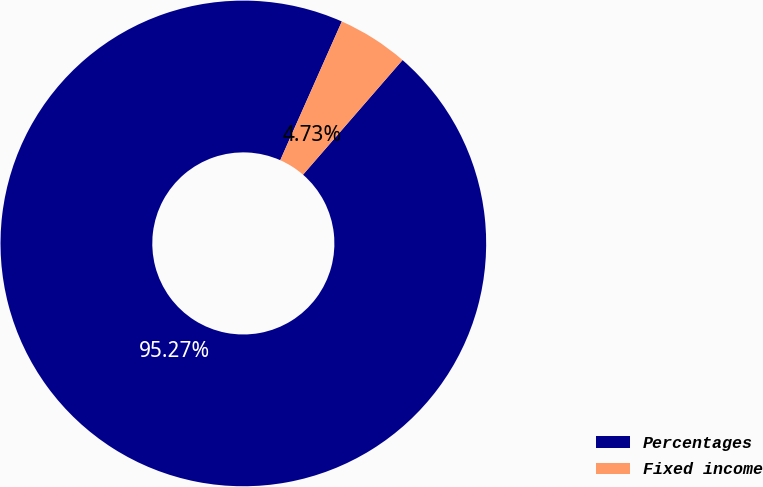Convert chart. <chart><loc_0><loc_0><loc_500><loc_500><pie_chart><fcel>Percentages<fcel>Fixed income<nl><fcel>95.27%<fcel>4.73%<nl></chart> 